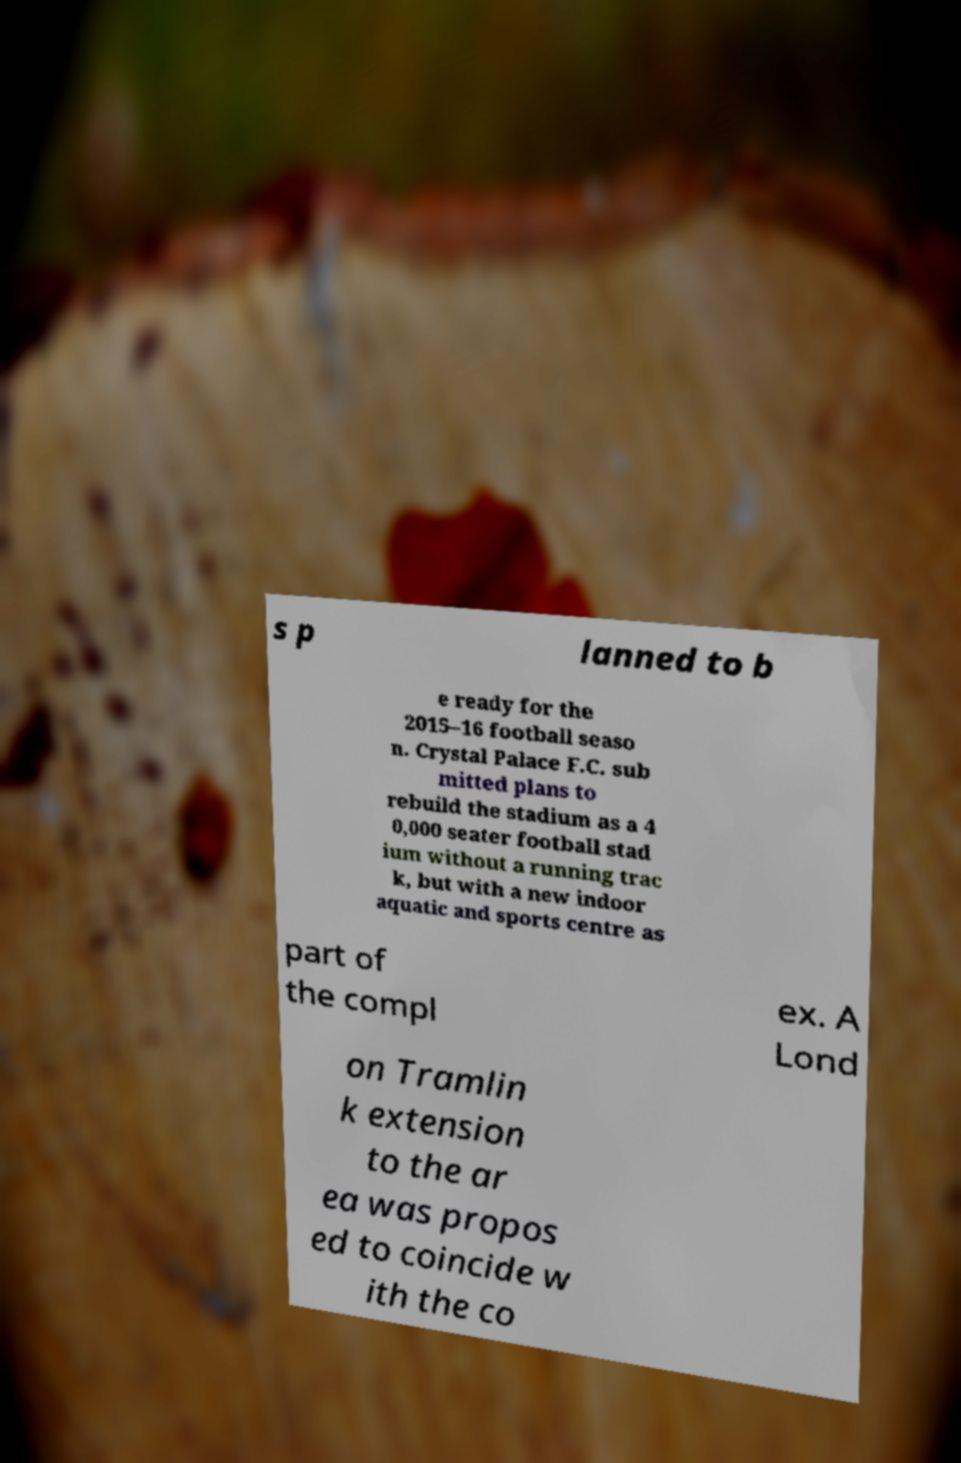Please read and relay the text visible in this image. What does it say? s p lanned to b e ready for the 2015–16 football seaso n. Crystal Palace F.C. sub mitted plans to rebuild the stadium as a 4 0,000 seater football stad ium without a running trac k, but with a new indoor aquatic and sports centre as part of the compl ex. A Lond on Tramlin k extension to the ar ea was propos ed to coincide w ith the co 